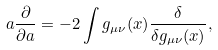Convert formula to latex. <formula><loc_0><loc_0><loc_500><loc_500>a { \frac { \partial } { \partial a } } = - 2 \int g _ { \mu \nu } ( x ) { \frac { \delta } { \delta g _ { \mu \nu } ( x ) } } ,</formula> 